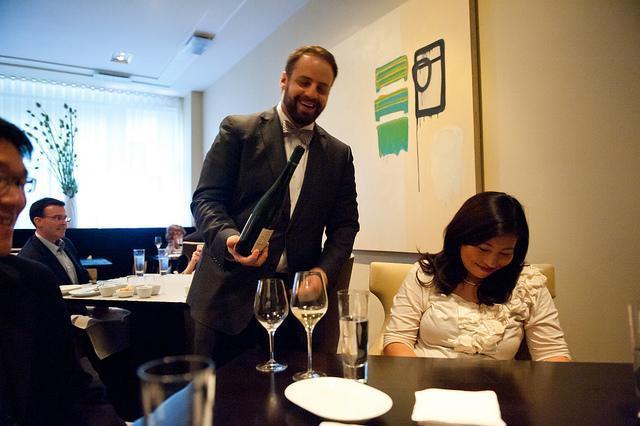How many dining tables are there?
Give a very brief answer. 2. How many people are there?
Give a very brief answer. 4. How many cups are in the photo?
Give a very brief answer. 2. 